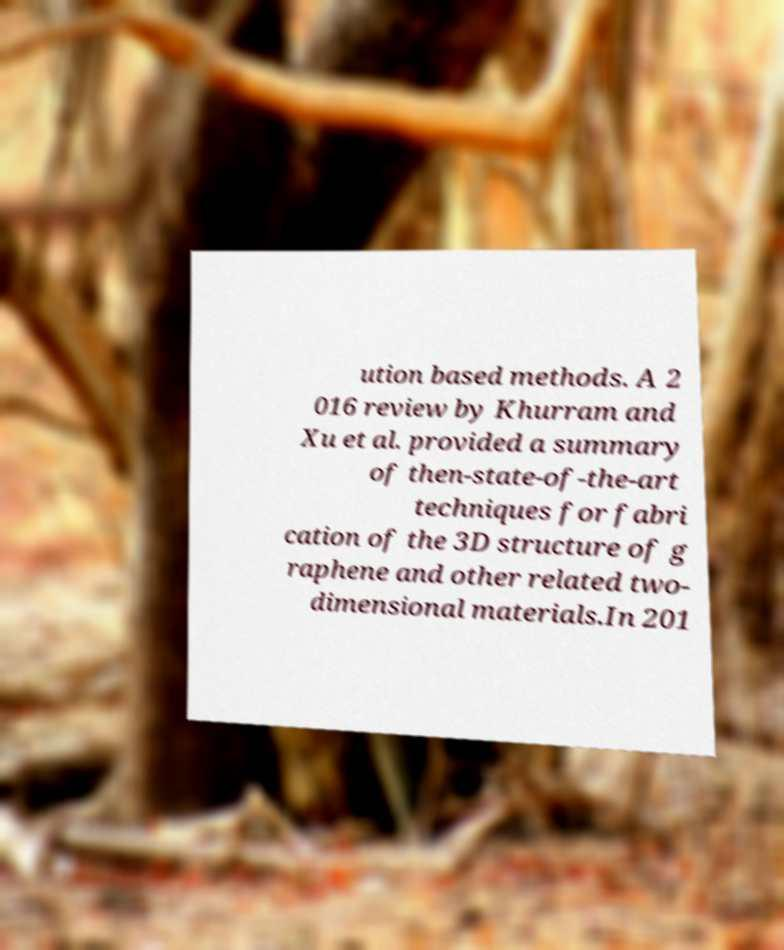Please identify and transcribe the text found in this image. ution based methods. A 2 016 review by Khurram and Xu et al. provided a summary of then-state-of-the-art techniques for fabri cation of the 3D structure of g raphene and other related two- dimensional materials.In 201 